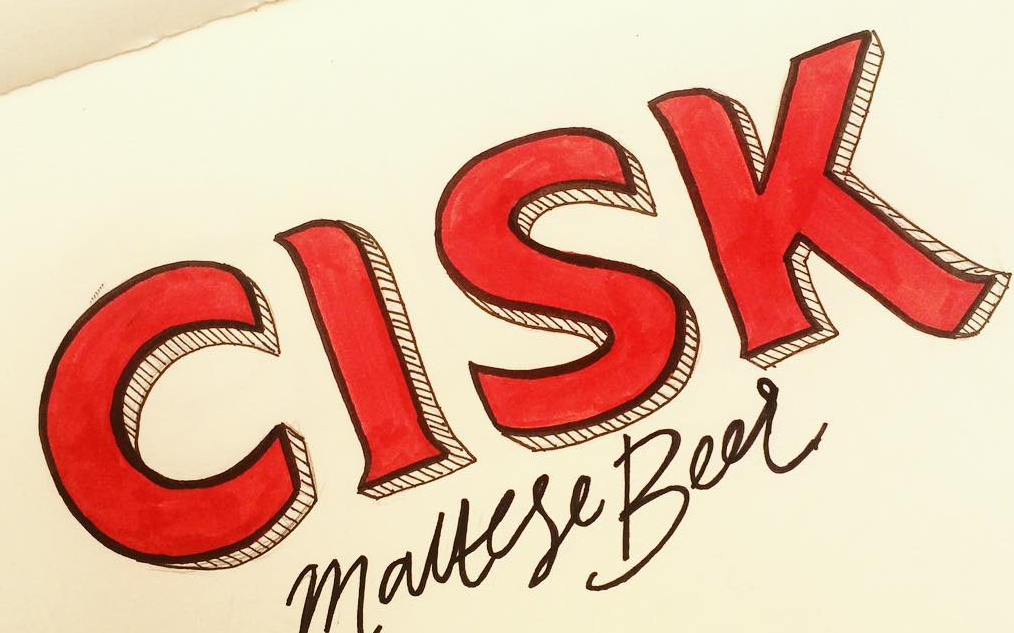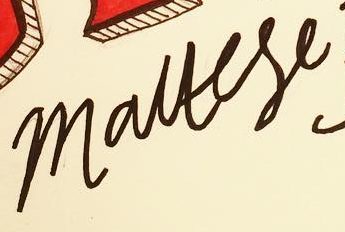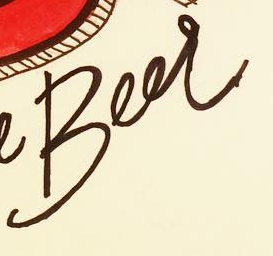What words are shown in these images in order, separated by a semicolon? CISK; mauese; Beer 